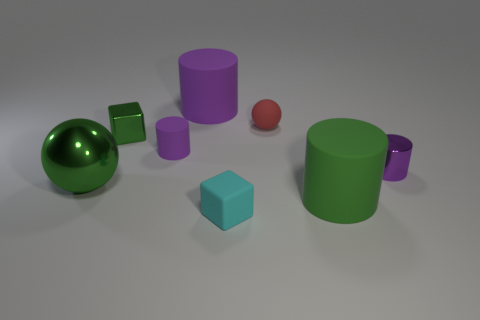There is a large object that is the same color as the metal cylinder; what is its material?
Provide a succinct answer. Rubber. What size is the cylinder that is the same color as the tiny shiny block?
Keep it short and to the point. Large. The small rubber thing that is behind the metallic block has what shape?
Give a very brief answer. Sphere. There is a large matte cylinder behind the purple thing that is right of the cyan rubber cube; what number of purple matte cylinders are in front of it?
Make the answer very short. 1. There is a red sphere; is its size the same as the green shiny thing in front of the metal cylinder?
Offer a terse response. No. There is a purple rubber cylinder behind the small metallic object behind the small rubber cylinder; how big is it?
Your answer should be compact. Large. What number of things are made of the same material as the large green sphere?
Ensure brevity in your answer.  2. Are any tiny purple metallic balls visible?
Ensure brevity in your answer.  No. There is a cube behind the cyan object; how big is it?
Make the answer very short. Small. What number of other blocks have the same color as the metal block?
Offer a terse response. 0. 